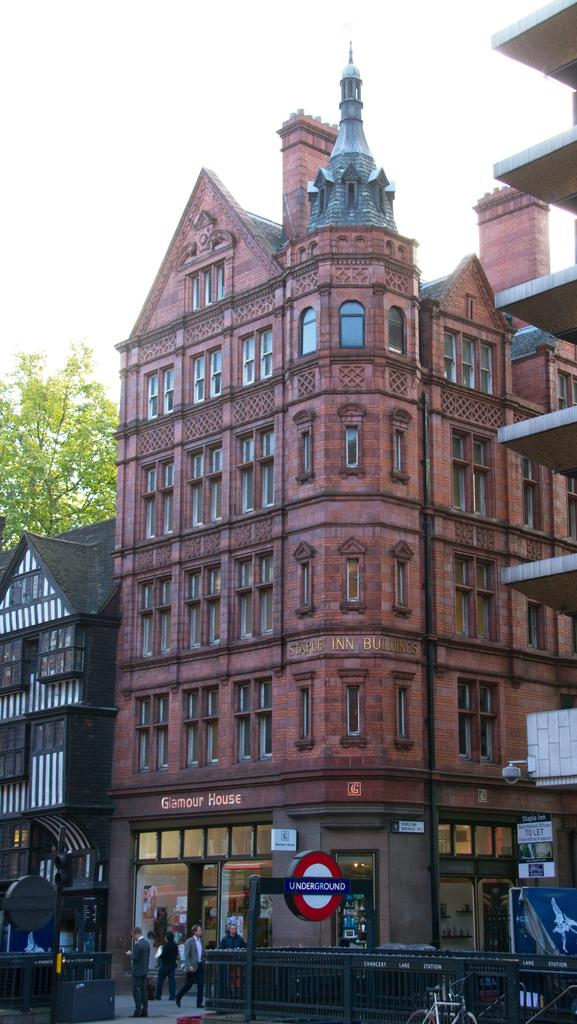What is the color of the building in the image? The building in the image is red. What is happening in front of the building? There are persons in front of the building. What can be seen at the top of the image? The sky is visible at the top of the image. What type of vegetation is present in the image? There is a tree in the image. Is there a band playing in front of the building in the image? There is no band present in the image. Can you see any flames coming from the building in the image? There are no flames visible in the image. 